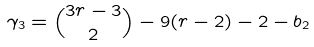Convert formula to latex. <formula><loc_0><loc_0><loc_500><loc_500>\gamma _ { 3 } & = \binom { 3 r - 3 } { 2 } - 9 ( r - 2 ) - 2 - b _ { 2 }</formula> 